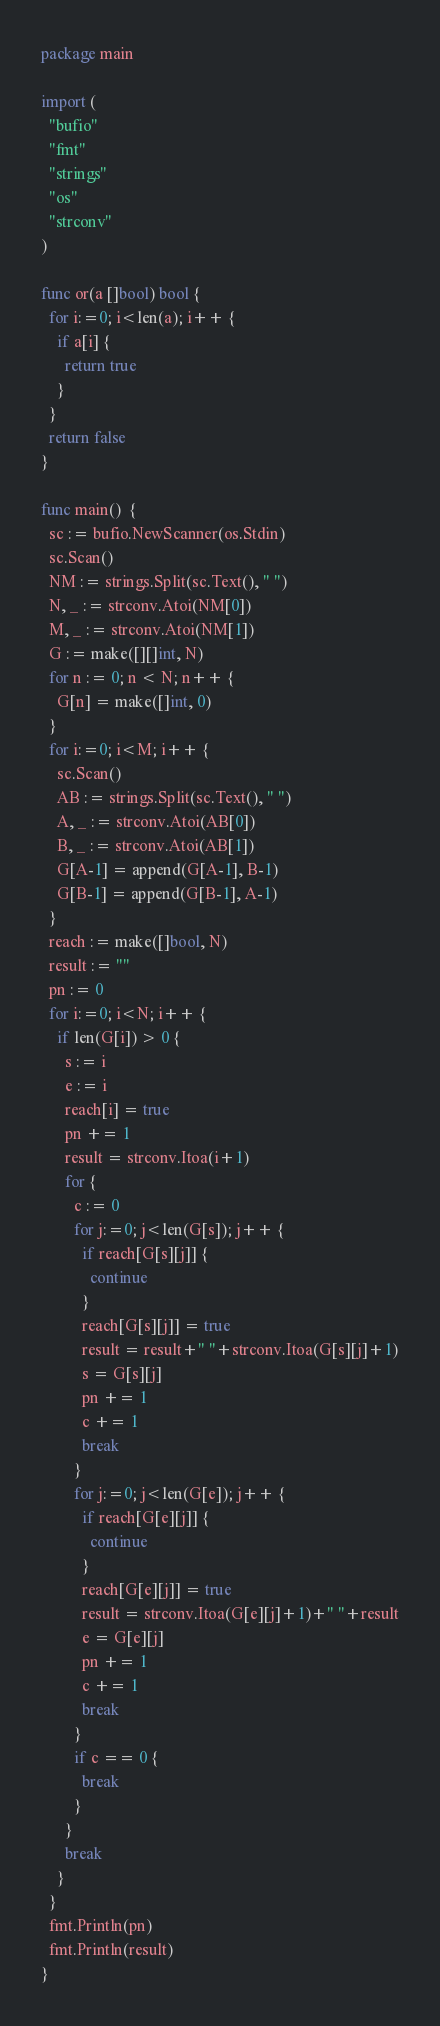Convert code to text. <code><loc_0><loc_0><loc_500><loc_500><_Go_>package main

import (
  "bufio"
  "fmt"
  "strings"
  "os"
  "strconv"
)

func or(a []bool) bool {
  for i:=0; i<len(a); i++ {
    if a[i] {
      return true
    }
  }
  return false
}

func main()  {
  sc := bufio.NewScanner(os.Stdin)
  sc.Scan()
  NM := strings.Split(sc.Text(), " ")
  N, _ := strconv.Atoi(NM[0])
  M, _ := strconv.Atoi(NM[1])
  G := make([][]int, N)
  for n := 0; n < N; n++ {
    G[n] = make([]int, 0)
  }
  for i:=0; i<M; i++ {
    sc.Scan()
    AB := strings.Split(sc.Text(), " ")
    A, _ := strconv.Atoi(AB[0])
    B, _ := strconv.Atoi(AB[1])
    G[A-1] = append(G[A-1], B-1)
    G[B-1] = append(G[B-1], A-1)
  }
  reach := make([]bool, N)
  result := ""
  pn := 0
  for i:=0; i<N; i++ {
    if len(G[i]) > 0 {
      s := i
      e := i
      reach[i] = true
      pn += 1
      result = strconv.Itoa(i+1)
      for {
        c := 0
        for j:=0; j<len(G[s]); j++ {
          if reach[G[s][j]] {
            continue
          }
          reach[G[s][j]] = true
          result = result+" "+strconv.Itoa(G[s][j]+1)
          s = G[s][j]
          pn += 1
          c += 1
          break
        }
        for j:=0; j<len(G[e]); j++ {
          if reach[G[e][j]] {
            continue
          }
          reach[G[e][j]] = true
          result = strconv.Itoa(G[e][j]+1)+" "+result
          e = G[e][j]
          pn += 1
          c += 1
          break
        }
        if c == 0 {
          break
        }
      }
      break
    }
  }
  fmt.Println(pn)
  fmt.Println(result)
}
</code> 